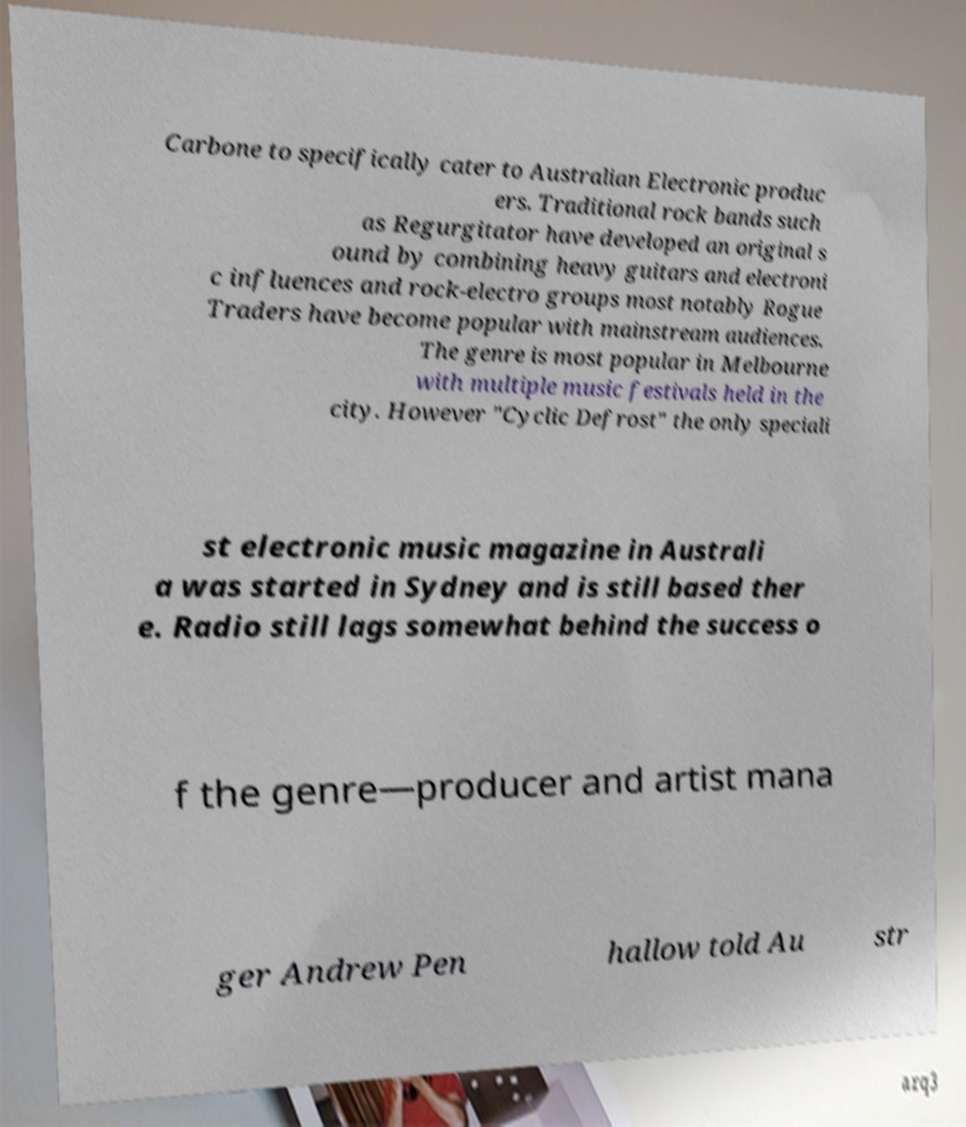There's text embedded in this image that I need extracted. Can you transcribe it verbatim? Carbone to specifically cater to Australian Electronic produc ers. Traditional rock bands such as Regurgitator have developed an original s ound by combining heavy guitars and electroni c influences and rock-electro groups most notably Rogue Traders have become popular with mainstream audiences. The genre is most popular in Melbourne with multiple music festivals held in the city. However "Cyclic Defrost" the only speciali st electronic music magazine in Australi a was started in Sydney and is still based ther e. Radio still lags somewhat behind the success o f the genre—producer and artist mana ger Andrew Pen hallow told Au str 